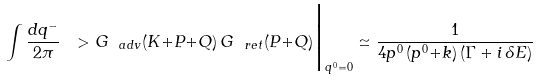<formula> <loc_0><loc_0><loc_500><loc_500>\int \frac { d q ^ { - } } { 2 \pi } \ > G _ { \ a d v } ( K { + } P { + } Q ) \, G _ { \ r e t } ( P { + } Q ) \Big | _ { q ^ { 0 } = 0 } \simeq \frac { 1 } { 4 p ^ { 0 } \, ( p ^ { 0 } { + } k ) \, ( \Gamma + i \, \delta E ) }</formula> 